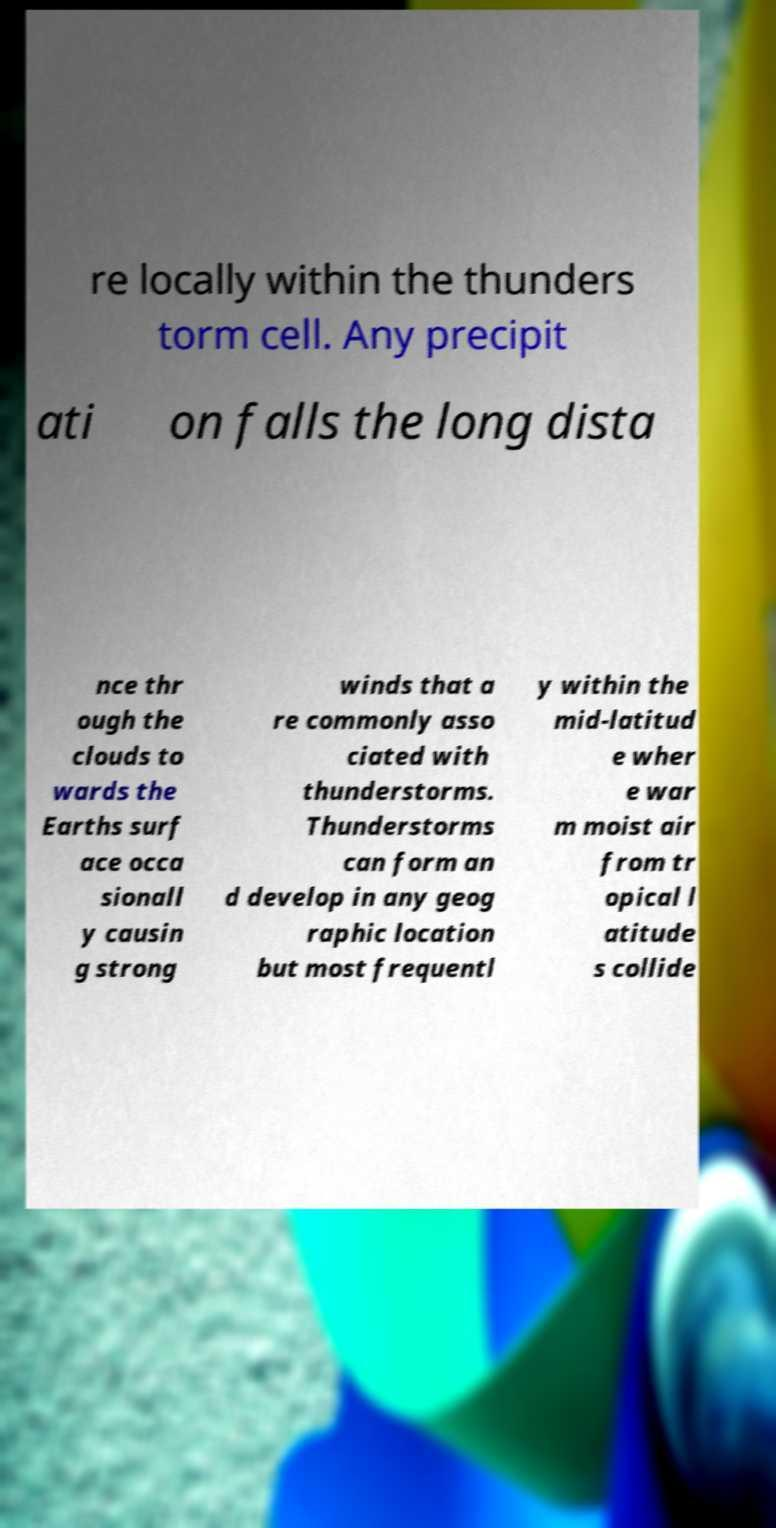Please identify and transcribe the text found in this image. re locally within the thunders torm cell. Any precipit ati on falls the long dista nce thr ough the clouds to wards the Earths surf ace occa sionall y causin g strong winds that a re commonly asso ciated with thunderstorms. Thunderstorms can form an d develop in any geog raphic location but most frequentl y within the mid-latitud e wher e war m moist air from tr opical l atitude s collide 